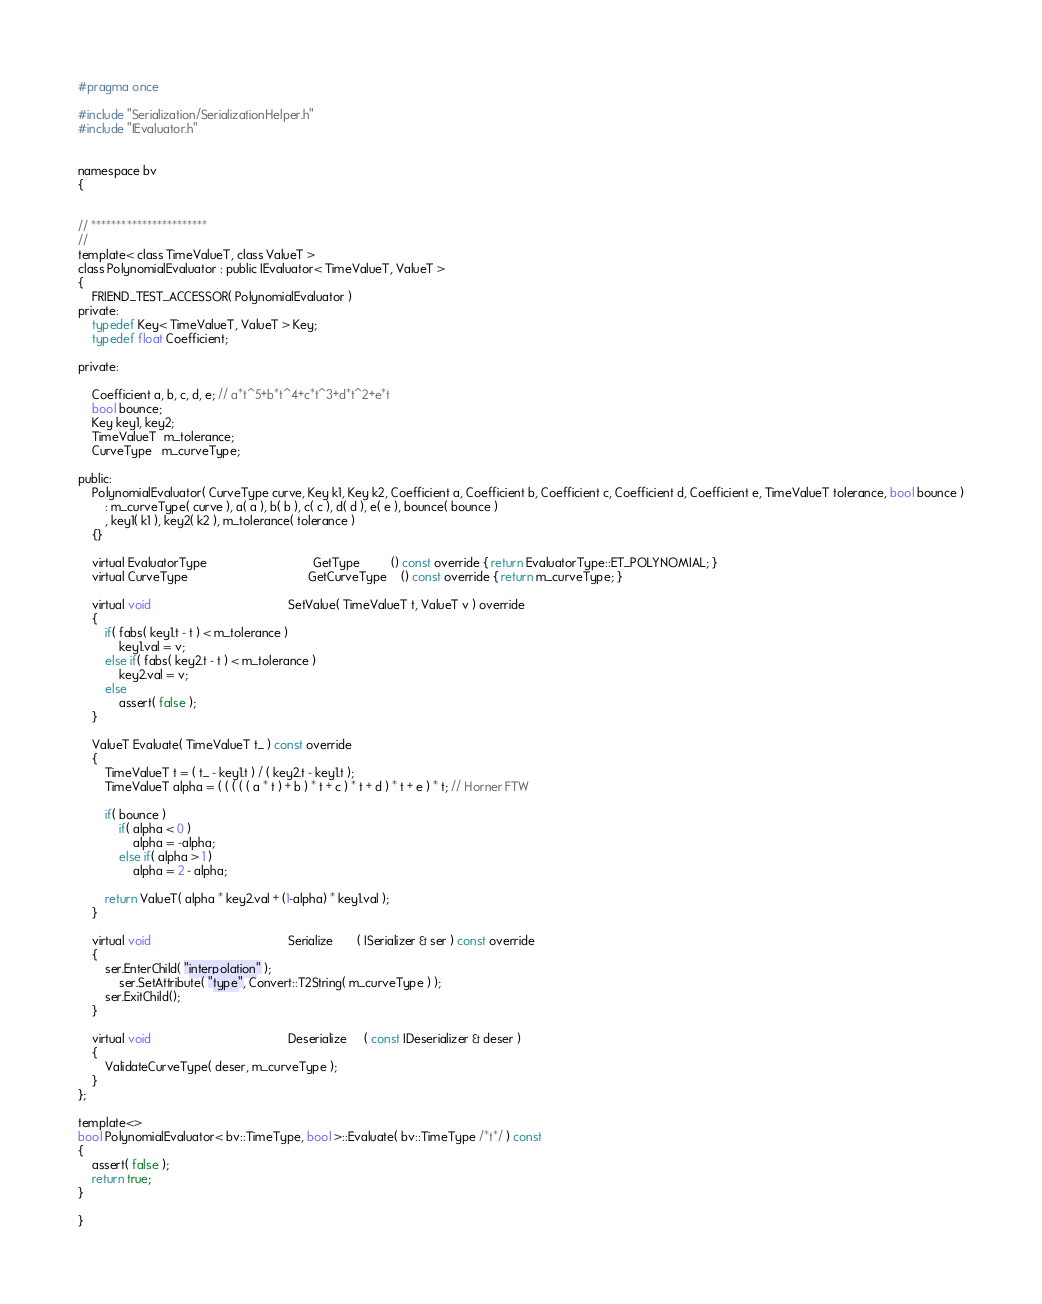Convert code to text. <code><loc_0><loc_0><loc_500><loc_500><_C_>#pragma once

#include "Serialization/SerializationHelper.h"
#include "IEvaluator.h"


namespace bv
{


// ***********************
//
template< class TimeValueT, class ValueT >
class PolynomialEvaluator : public IEvaluator< TimeValueT, ValueT >
{
    FRIEND_TEST_ACCESSOR( PolynomialEvaluator )
private:
    typedef Key< TimeValueT, ValueT > Key;
    typedef float Coefficient;

private:

    Coefficient a, b, c, d, e; // a*t^5+b*t^4+c*t^3+d*t^2+e*t
    bool bounce;
    Key key1, key2;
    TimeValueT  m_tolerance;
    CurveType   m_curveType;

public:
    PolynomialEvaluator( CurveType curve, Key k1, Key k2, Coefficient a, Coefficient b, Coefficient c, Coefficient d, Coefficient e, TimeValueT tolerance, bool bounce )
        : m_curveType( curve ), a( a ), b( b ), c( c ), d( d ), e( e ), bounce( bounce )
        , key1( k1 ), key2( k2 ), m_tolerance( tolerance )
    {}

    virtual EvaluatorType                               GetType         () const override { return EvaluatorType::ET_POLYNOMIAL; }
    virtual CurveType                                   GetCurveType    () const override { return m_curveType; }

    virtual void                                        SetValue( TimeValueT t, ValueT v ) override
    {
        if( fabs( key1.t - t ) < m_tolerance )
            key1.val = v;
        else if( fabs( key2.t - t ) < m_tolerance )
            key2.val = v;
        else
            assert( false );
    }

    ValueT Evaluate( TimeValueT t_ ) const override 
    { 
        TimeValueT t = ( t_ - key1.t ) / ( key2.t - key1.t );
        TimeValueT alpha = ( ( ( ( ( a * t ) + b ) * t + c ) * t + d ) * t + e ) * t; // Horner FTW

        if( bounce )
            if( alpha < 0 )
                alpha = -alpha;
            else if( alpha > 1 )
                alpha = 2 - alpha;

        return ValueT( alpha * key2.val + (1-alpha) * key1.val );
    }

    virtual void                                        Serialize       ( ISerializer & ser ) const override
    {
        ser.EnterChild( "interpolation" );
            ser.SetAttribute( "type", Convert::T2String( m_curveType ) );
        ser.ExitChild();
    }

    virtual void                                        Deserialize     ( const IDeserializer & deser )
    {
        ValidateCurveType( deser, m_curveType );
    }
};

template<>
bool PolynomialEvaluator< bv::TimeType, bool >::Evaluate( bv::TimeType /*t*/ ) const
{
    assert( false );
    return true;
}

}
</code> 